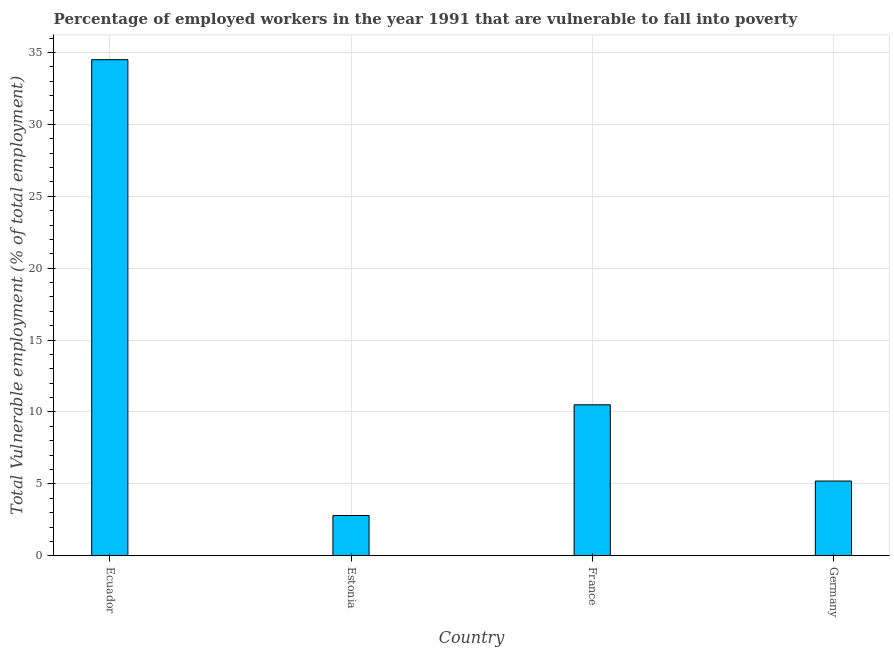Does the graph contain grids?
Your answer should be compact. Yes. What is the title of the graph?
Provide a short and direct response. Percentage of employed workers in the year 1991 that are vulnerable to fall into poverty. What is the label or title of the Y-axis?
Your answer should be compact. Total Vulnerable employment (% of total employment). What is the total vulnerable employment in Estonia?
Your answer should be very brief. 2.8. Across all countries, what is the maximum total vulnerable employment?
Keep it short and to the point. 34.5. Across all countries, what is the minimum total vulnerable employment?
Provide a short and direct response. 2.8. In which country was the total vulnerable employment maximum?
Provide a succinct answer. Ecuador. In which country was the total vulnerable employment minimum?
Provide a short and direct response. Estonia. What is the sum of the total vulnerable employment?
Offer a very short reply. 53. What is the difference between the total vulnerable employment in Estonia and France?
Ensure brevity in your answer.  -7.7. What is the average total vulnerable employment per country?
Provide a short and direct response. 13.25. What is the median total vulnerable employment?
Provide a short and direct response. 7.85. What is the ratio of the total vulnerable employment in Estonia to that in Germany?
Offer a very short reply. 0.54. Is the total vulnerable employment in Ecuador less than that in France?
Offer a very short reply. No. Is the difference between the total vulnerable employment in France and Germany greater than the difference between any two countries?
Keep it short and to the point. No. What is the difference between the highest and the lowest total vulnerable employment?
Keep it short and to the point. 31.7. How many countries are there in the graph?
Make the answer very short. 4. What is the Total Vulnerable employment (% of total employment) of Ecuador?
Keep it short and to the point. 34.5. What is the Total Vulnerable employment (% of total employment) in Estonia?
Make the answer very short. 2.8. What is the Total Vulnerable employment (% of total employment) in Germany?
Provide a short and direct response. 5.2. What is the difference between the Total Vulnerable employment (% of total employment) in Ecuador and Estonia?
Provide a short and direct response. 31.7. What is the difference between the Total Vulnerable employment (% of total employment) in Ecuador and Germany?
Give a very brief answer. 29.3. What is the difference between the Total Vulnerable employment (% of total employment) in Estonia and France?
Make the answer very short. -7.7. What is the difference between the Total Vulnerable employment (% of total employment) in Estonia and Germany?
Keep it short and to the point. -2.4. What is the difference between the Total Vulnerable employment (% of total employment) in France and Germany?
Provide a short and direct response. 5.3. What is the ratio of the Total Vulnerable employment (% of total employment) in Ecuador to that in Estonia?
Offer a terse response. 12.32. What is the ratio of the Total Vulnerable employment (% of total employment) in Ecuador to that in France?
Make the answer very short. 3.29. What is the ratio of the Total Vulnerable employment (% of total employment) in Ecuador to that in Germany?
Ensure brevity in your answer.  6.63. What is the ratio of the Total Vulnerable employment (% of total employment) in Estonia to that in France?
Ensure brevity in your answer.  0.27. What is the ratio of the Total Vulnerable employment (% of total employment) in Estonia to that in Germany?
Offer a very short reply. 0.54. What is the ratio of the Total Vulnerable employment (% of total employment) in France to that in Germany?
Your answer should be compact. 2.02. 